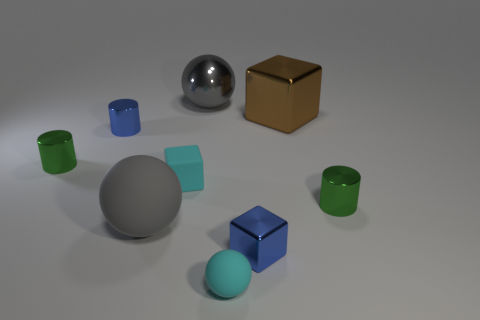Subtract all cubes. How many objects are left? 6 Add 3 purple spheres. How many purple spheres exist? 3 Subtract 0 yellow cylinders. How many objects are left? 9 Subtract all big gray cylinders. Subtract all large objects. How many objects are left? 6 Add 3 tiny blue objects. How many tiny blue objects are left? 5 